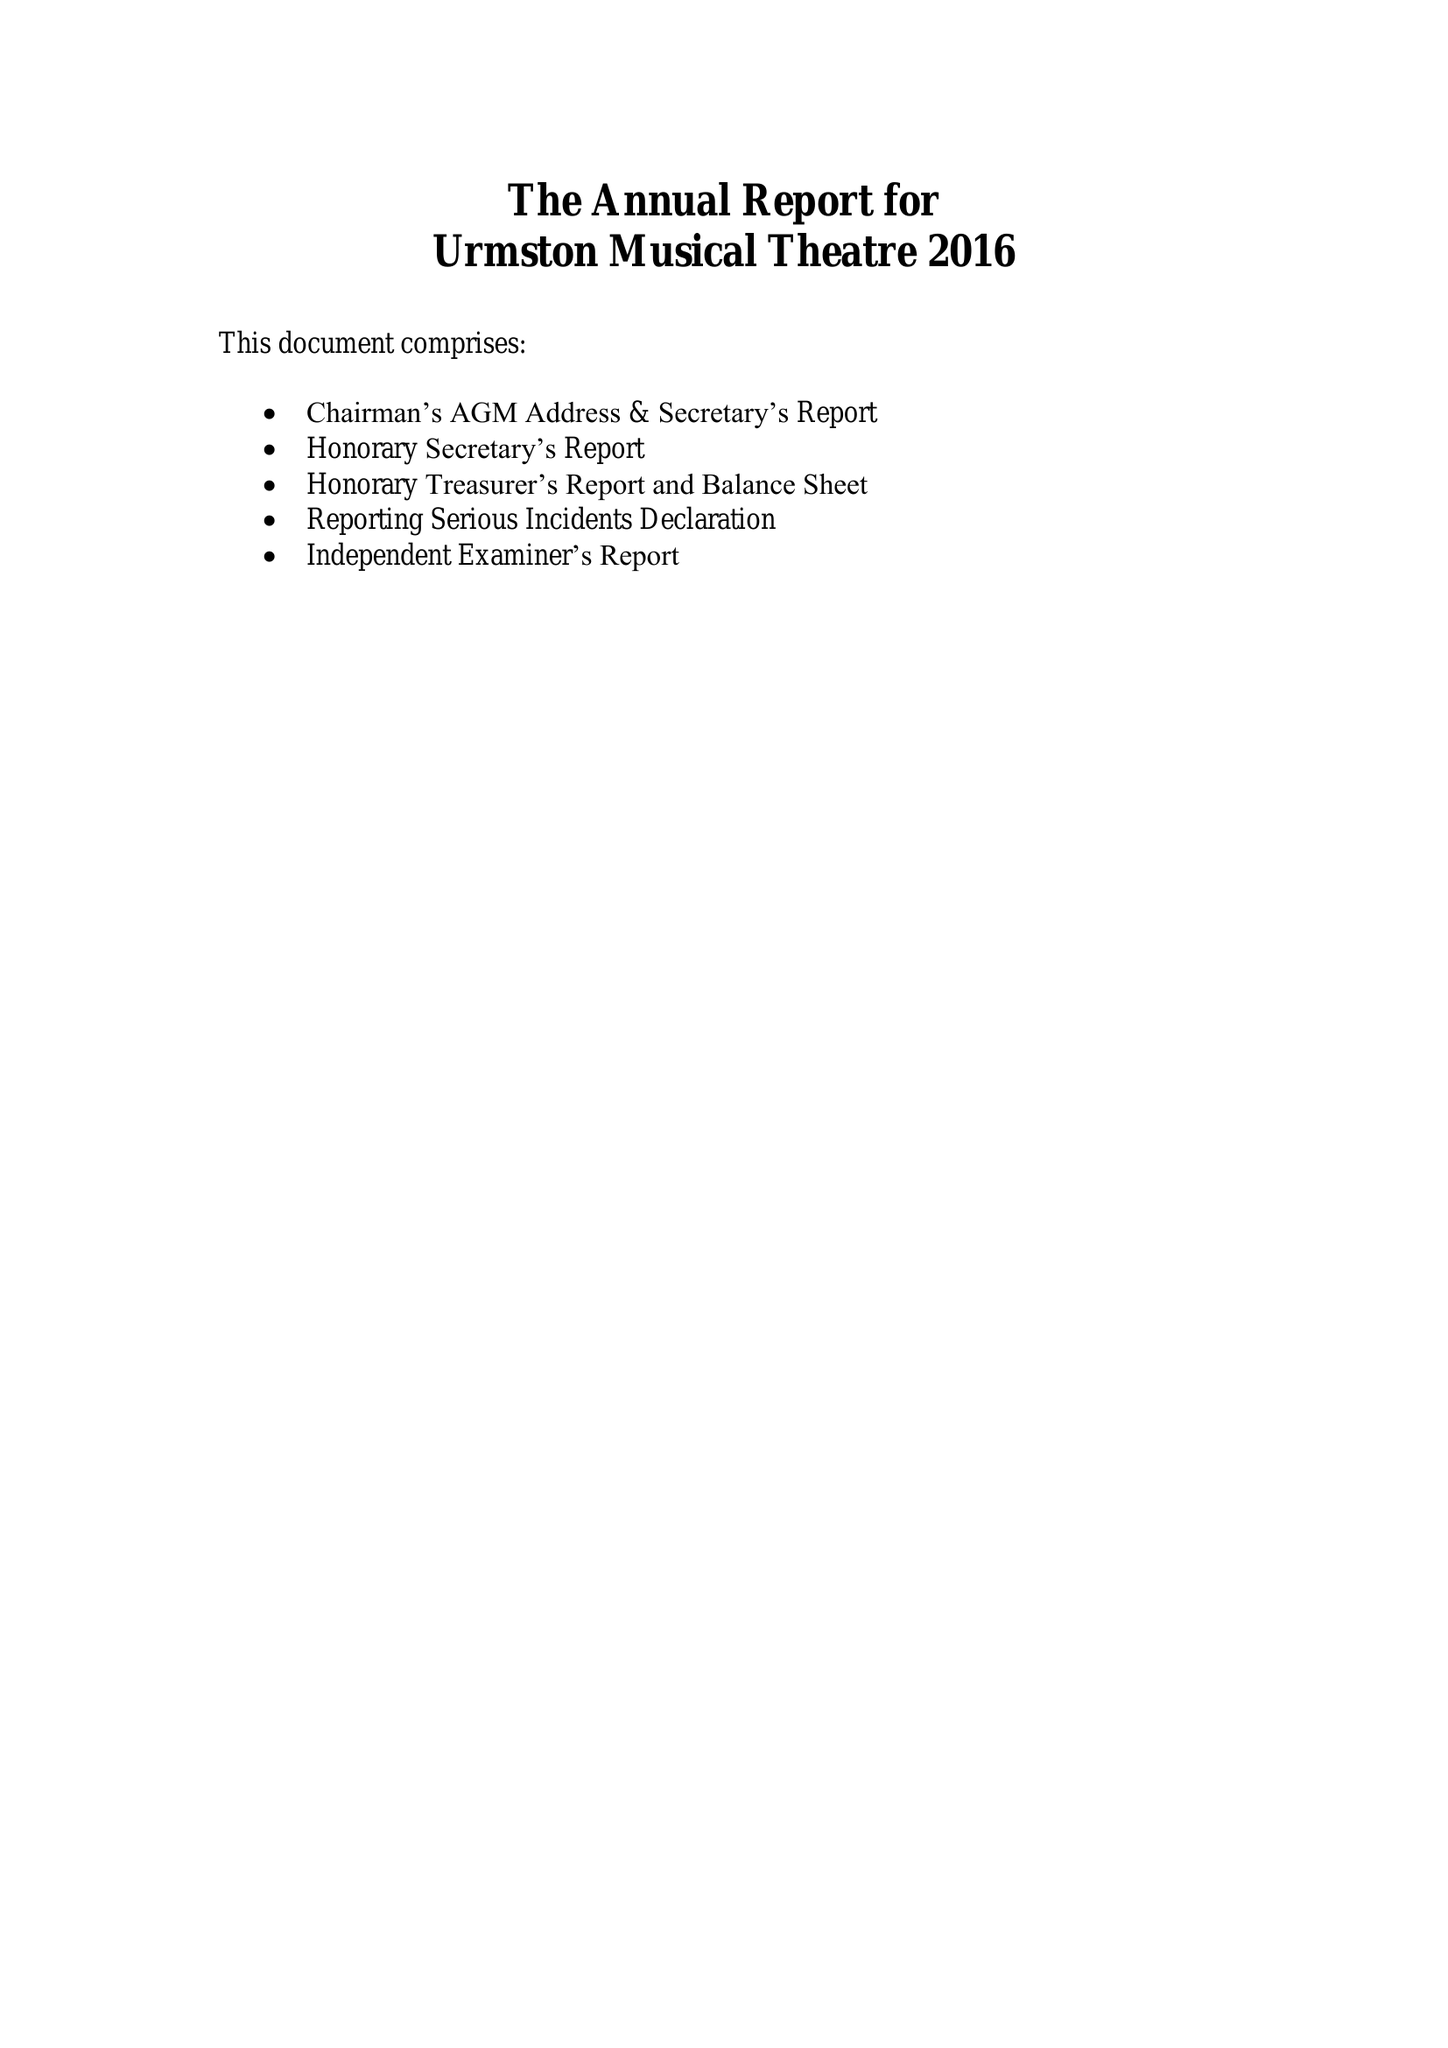What is the value for the income_annually_in_british_pounds?
Answer the question using a single word or phrase. 34591.00 